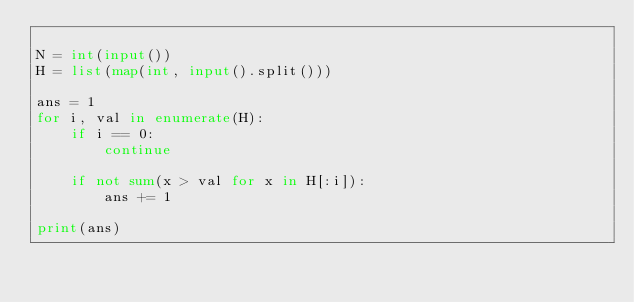<code> <loc_0><loc_0><loc_500><loc_500><_Python_>
N = int(input())
H = list(map(int, input().split()))

ans = 1
for i, val in enumerate(H):
    if i == 0:
        continue

    if not sum(x > val for x in H[:i]):
        ans += 1

print(ans)
</code> 